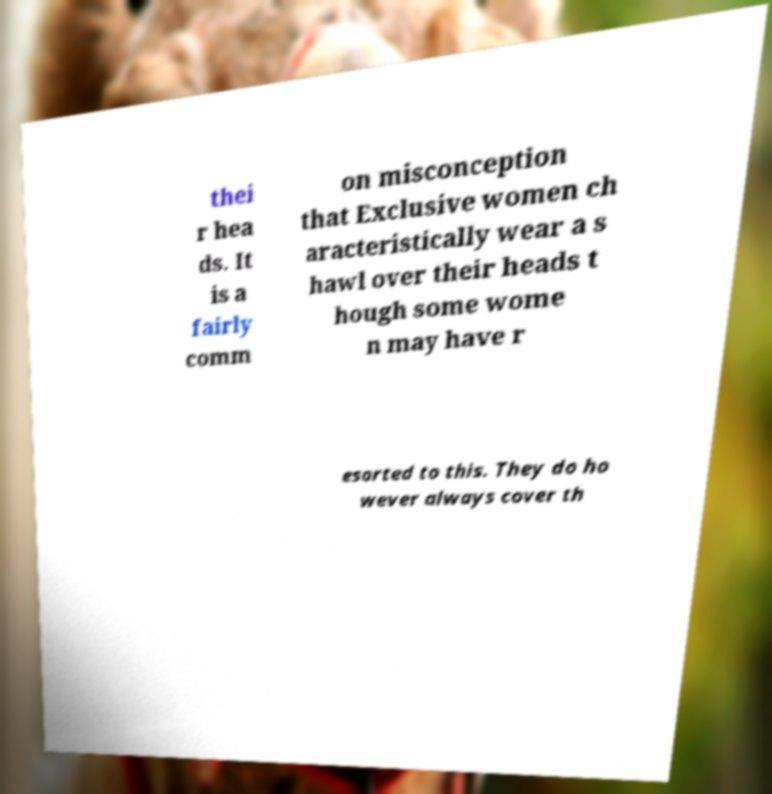Could you extract and type out the text from this image? thei r hea ds. It is a fairly comm on misconception that Exclusive women ch aracteristically wear a s hawl over their heads t hough some wome n may have r esorted to this. They do ho wever always cover th 